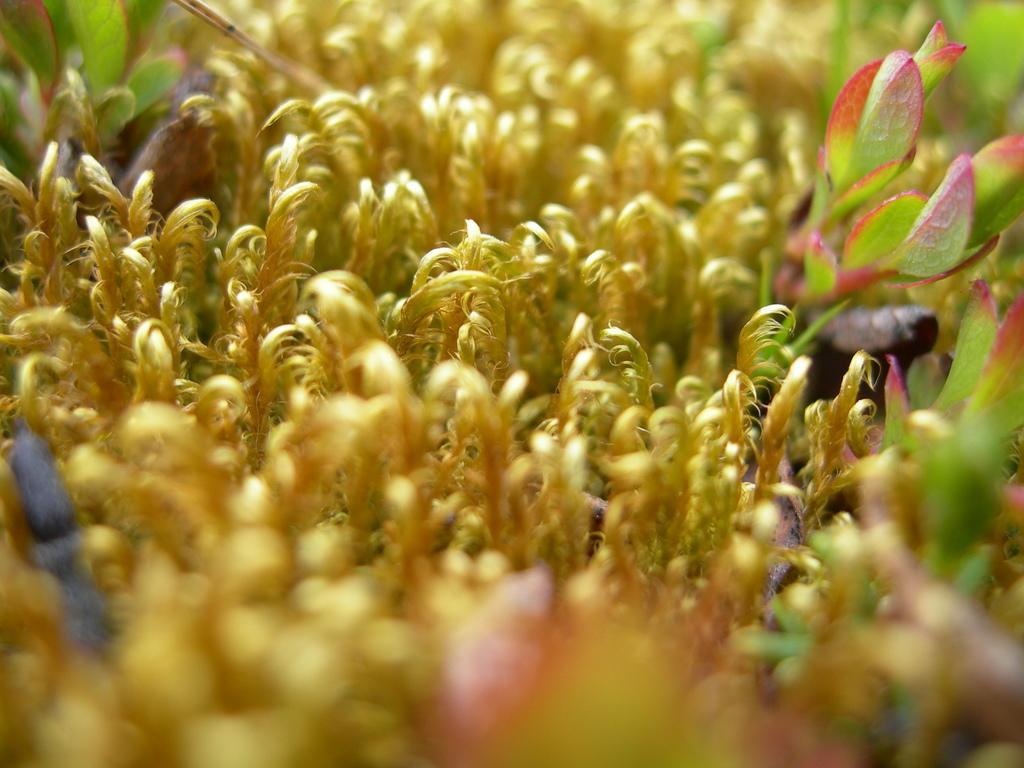Could you give a brief overview of what you see in this image? In the image we can see there are plants. 